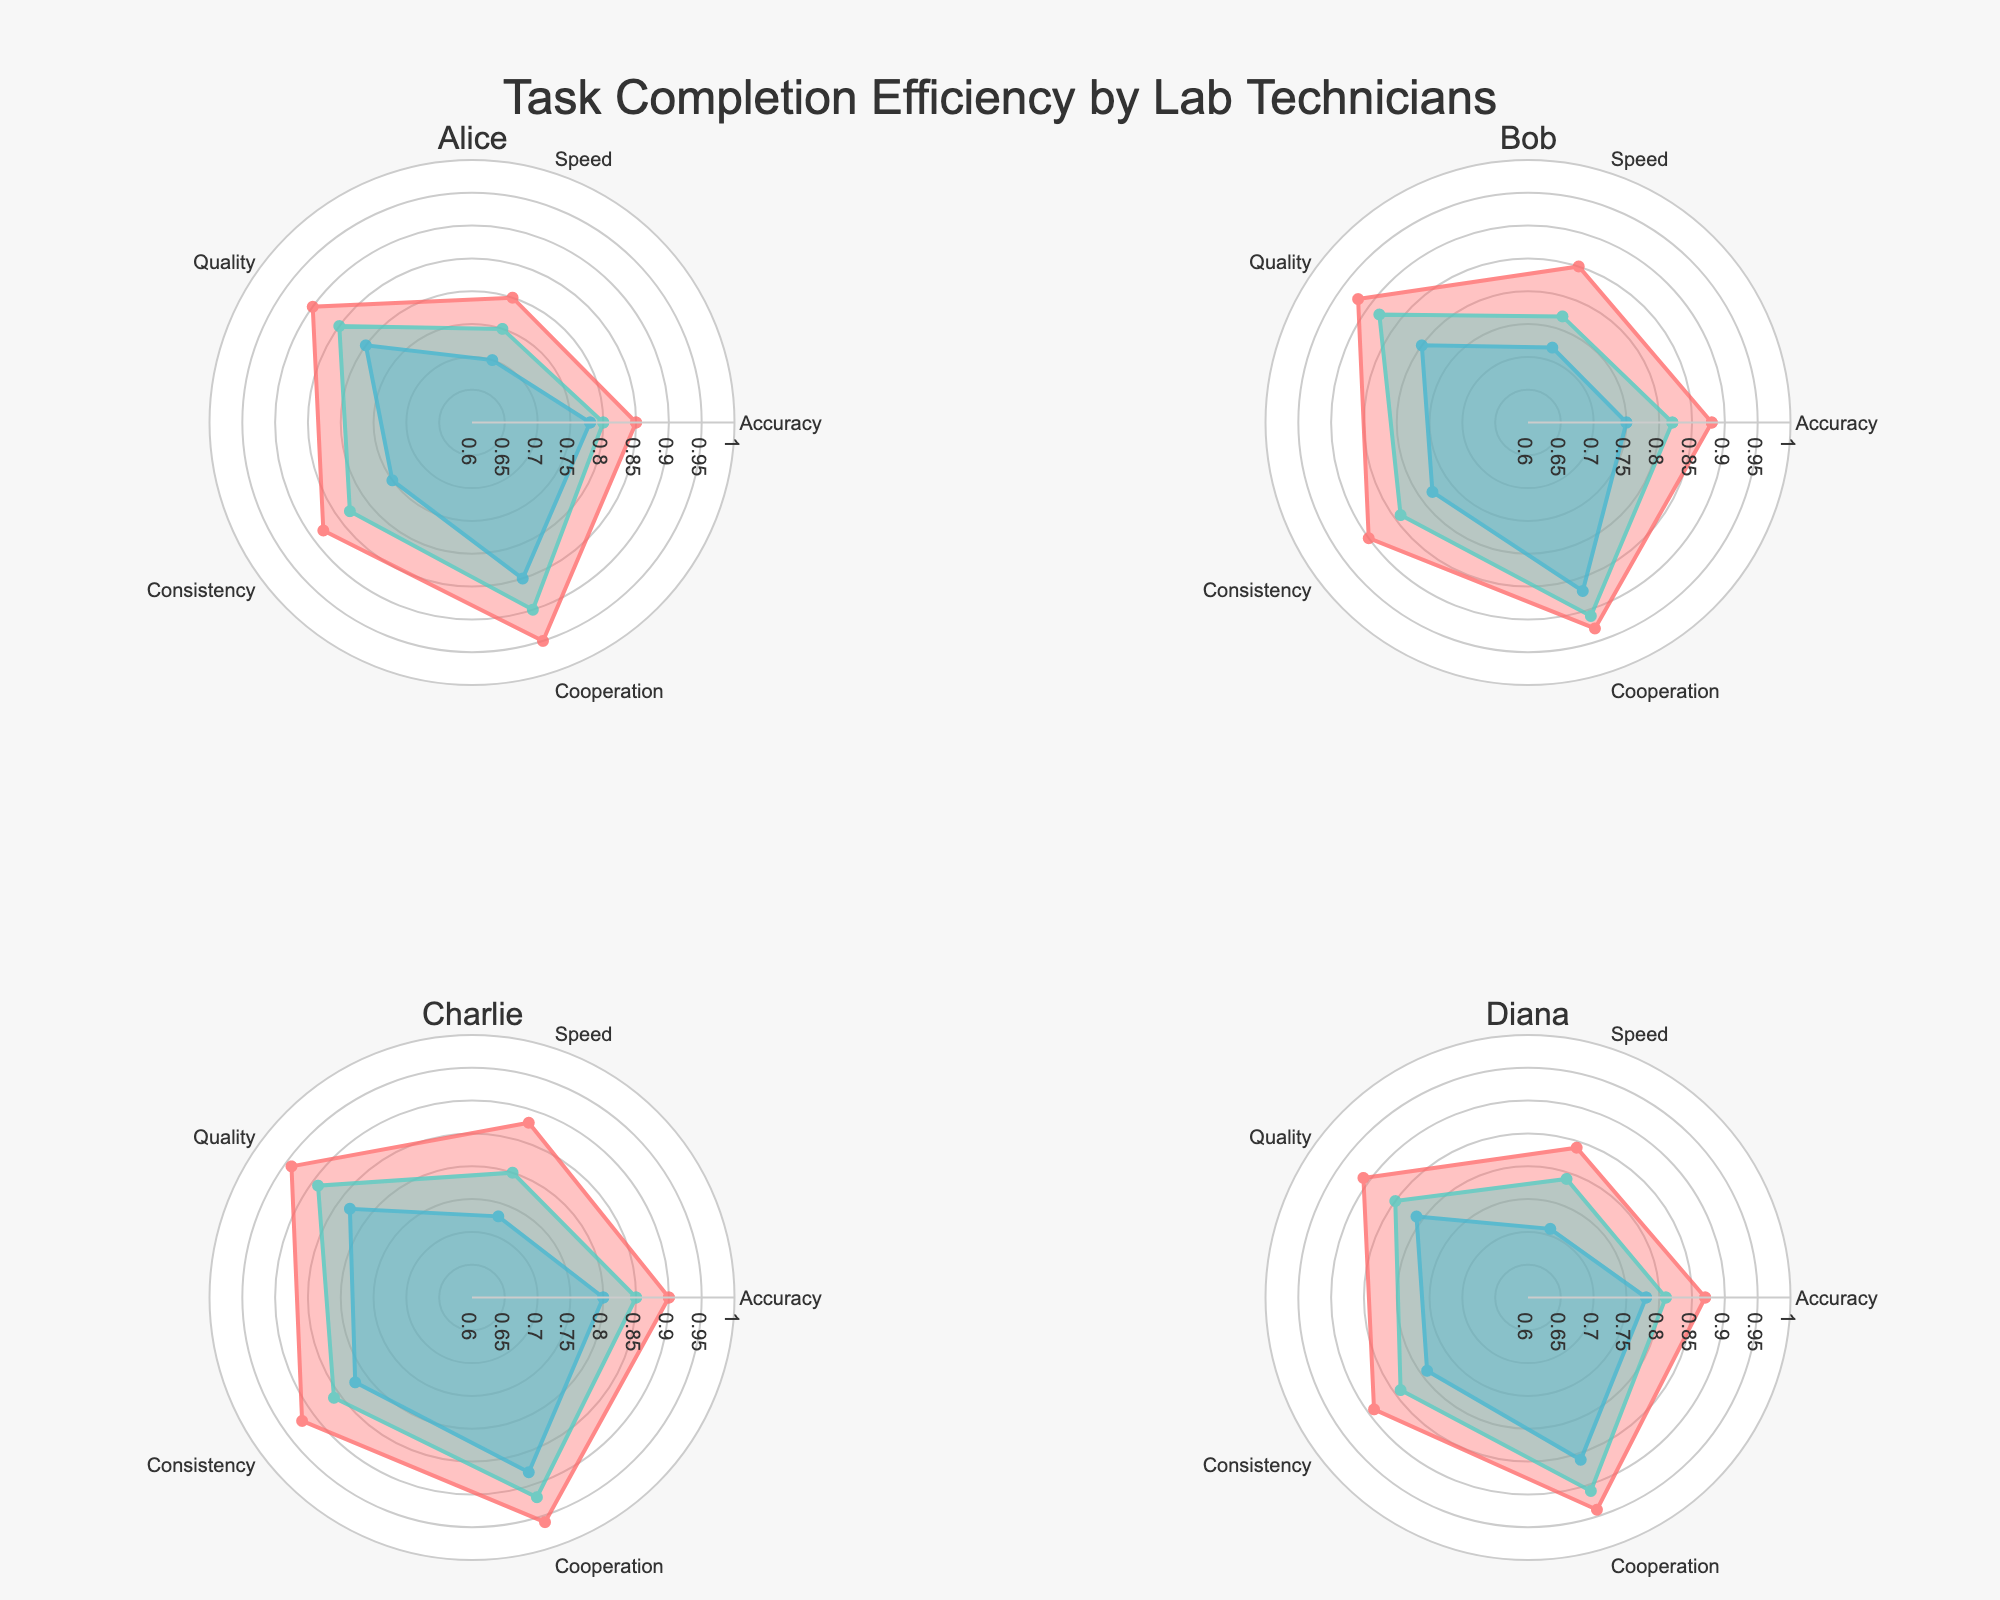How many technicians are included in the plots? The plots have subplots for each technician, each represented by a subplot title. The titles indicate that there are four technicians.
Answer: 4 Which technician shows the highest accuracy from 08:00-12:00? From the figure, we compare the values of the 'Accuracy' metric across the different plots for the time slot 08:00-12:00. Charlie has the highest accuracy in that time slot.
Answer: Charlie What is the average speed score for Alice across all time slots? Calculate Alice’s speed scores for 08:00-12:00 (0.80), 12:00-16:00 (0.75), and 16:00-20:00 (0.70). Then, sum these values and divide by 3. (0.80 + 0.75 + 0.70) / 3 = 0.75
Answer: 0.75 Between Bob and Diana, who shows more consistency in the 12:00-16:00 time slot? To determine this, compare the 'Consistency' values for Bob and Diana at the 12:00-16:00 time slot. Bob has a consistency of 0.84 and Diana has 0.84. Both are equal.
Answer: Both are equal Which technician has the most significant drop in speed from 08:00-12:00 to 16:00-20:00? Examine the difference in speed scores for each technician across the two time slots: Alice (0.80 to 0.70, difference of 0.10), Bob (0.85 to 0.72, difference of 0.13), Charlie (0.88 to 0.73, difference of 0.15), and Diana (0.84 to 0.71, difference of 0.13). Charlie has the most significant drop (0.15).
Answer: Charlie Which time slot shows the highest quality score for all technicians combined? Compare the quality scores for each time slot: 08:00-12:00, 12:00-16:00, and 16:00-20:00, by summing the respective values for each technician. The highest sum is found in the time slot 08:00-12:00.
Answer: 08:00-12:00 How does Charlie’s cooperation score at 08:00-12:00 compare to Alice’s cooperation score at 16:00-20:00? Compare the cooperation scores: Charlie’s cooperation score at 08:00-12:00 is 0.96, and Alice’s cooperation score at 16:00-20:00 is 0.85. Charlie’s score is higher.
Answer: Charlie’s score is higher Which technician has the most balanced performance (least variability) in Accuracy, Speed, Quality, Consistency, and Cooperation during the 08:00-12:00 time slot? To find the most balanced performance, compare the range (max-min) within each technician's radar chart for 08:00-12:00. Charlie’s values are the closest in range.
Answer: Charlie 